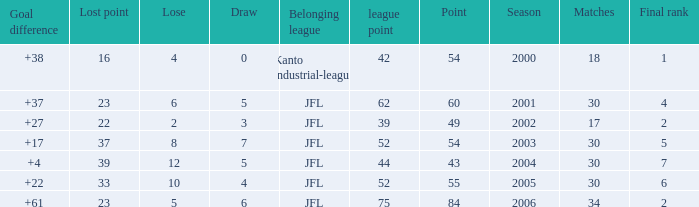Tell me the highest point with lost point being 33 and league point less than 52 None. 